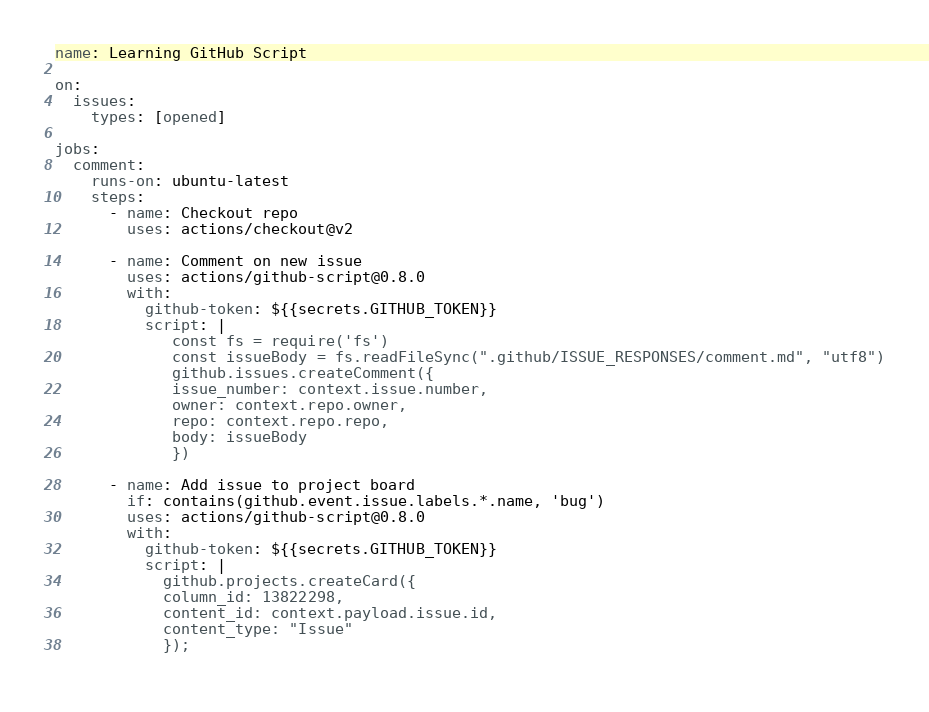Convert code to text. <code><loc_0><loc_0><loc_500><loc_500><_YAML_>name: Learning GitHub Script

on:
  issues:
    types: [opened]

jobs:
  comment:
    runs-on: ubuntu-latest
    steps:
      - name: Checkout repo
        uses: actions/checkout@v2

      - name: Comment on new issue
        uses: actions/github-script@0.8.0
        with:
          github-token: ${{secrets.GITHUB_TOKEN}}
          script: |
             const fs = require('fs')
             const issueBody = fs.readFileSync(".github/ISSUE_RESPONSES/comment.md", "utf8")
             github.issues.createComment({
             issue_number: context.issue.number,
             owner: context.repo.owner,
             repo: context.repo.repo,
             body: issueBody
             })

      - name: Add issue to project board
        if: contains(github.event.issue.labels.*.name, 'bug')
        uses: actions/github-script@0.8.0
        with:
          github-token: ${{secrets.GITHUB_TOKEN}}
          script: |
            github.projects.createCard({
            column_id: 13822298,
            content_id: context.payload.issue.id,
            content_type: "Issue"
            });
            
</code> 